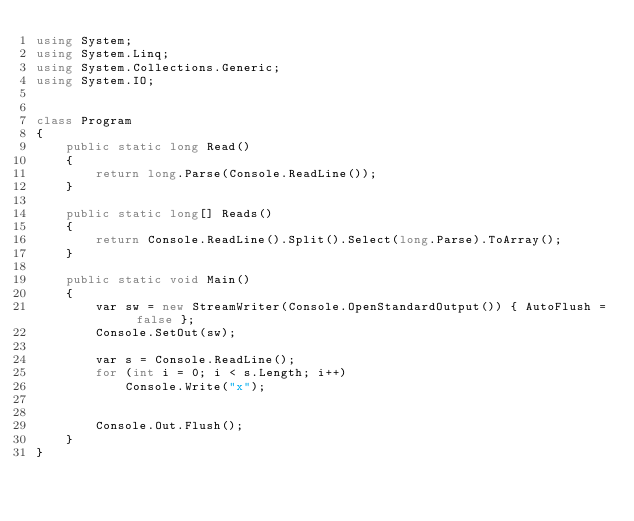Convert code to text. <code><loc_0><loc_0><loc_500><loc_500><_C#_>using System;
using System.Linq;
using System.Collections.Generic;
using System.IO;


class Program
{
    public static long Read()
    {
        return long.Parse(Console.ReadLine());
    }

    public static long[] Reads()
    {
        return Console.ReadLine().Split().Select(long.Parse).ToArray();
    }
    
    public static void Main()
    {
        var sw = new StreamWriter(Console.OpenStandardOutput()) { AutoFlush = false };
        Console.SetOut(sw);

        var s = Console.ReadLine();
        for (int i = 0; i < s.Length; i++)
            Console.Write("x");


        Console.Out.Flush();
    }
}
</code> 